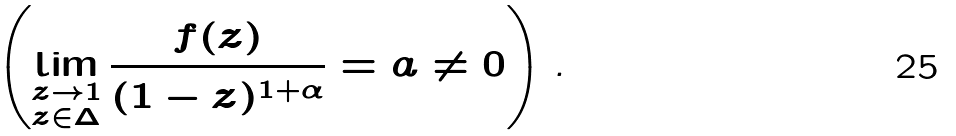Convert formula to latex. <formula><loc_0><loc_0><loc_500><loc_500>\left ( \lim _ { \substack { z \rightarrow 1 \\ z \in \Delta } } \frac { f ( z ) } { ( 1 - z ) ^ { 1 + \alpha } } = a \neq 0 \right ) \text {.}</formula> 